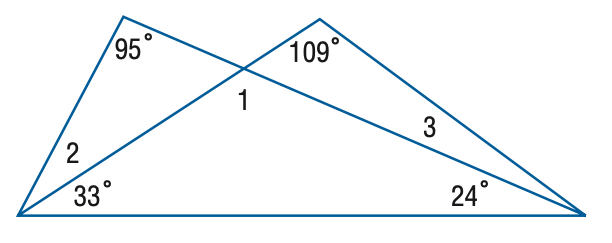Question: Find the measure of \angle 3.
Choices:
A. 13
B. 14
C. 15
D. 18
Answer with the letter. Answer: B Question: Find the measure of \angle 1.
Choices:
A. 95
B. 109
C. 123
D. 137
Answer with the letter. Answer: C 